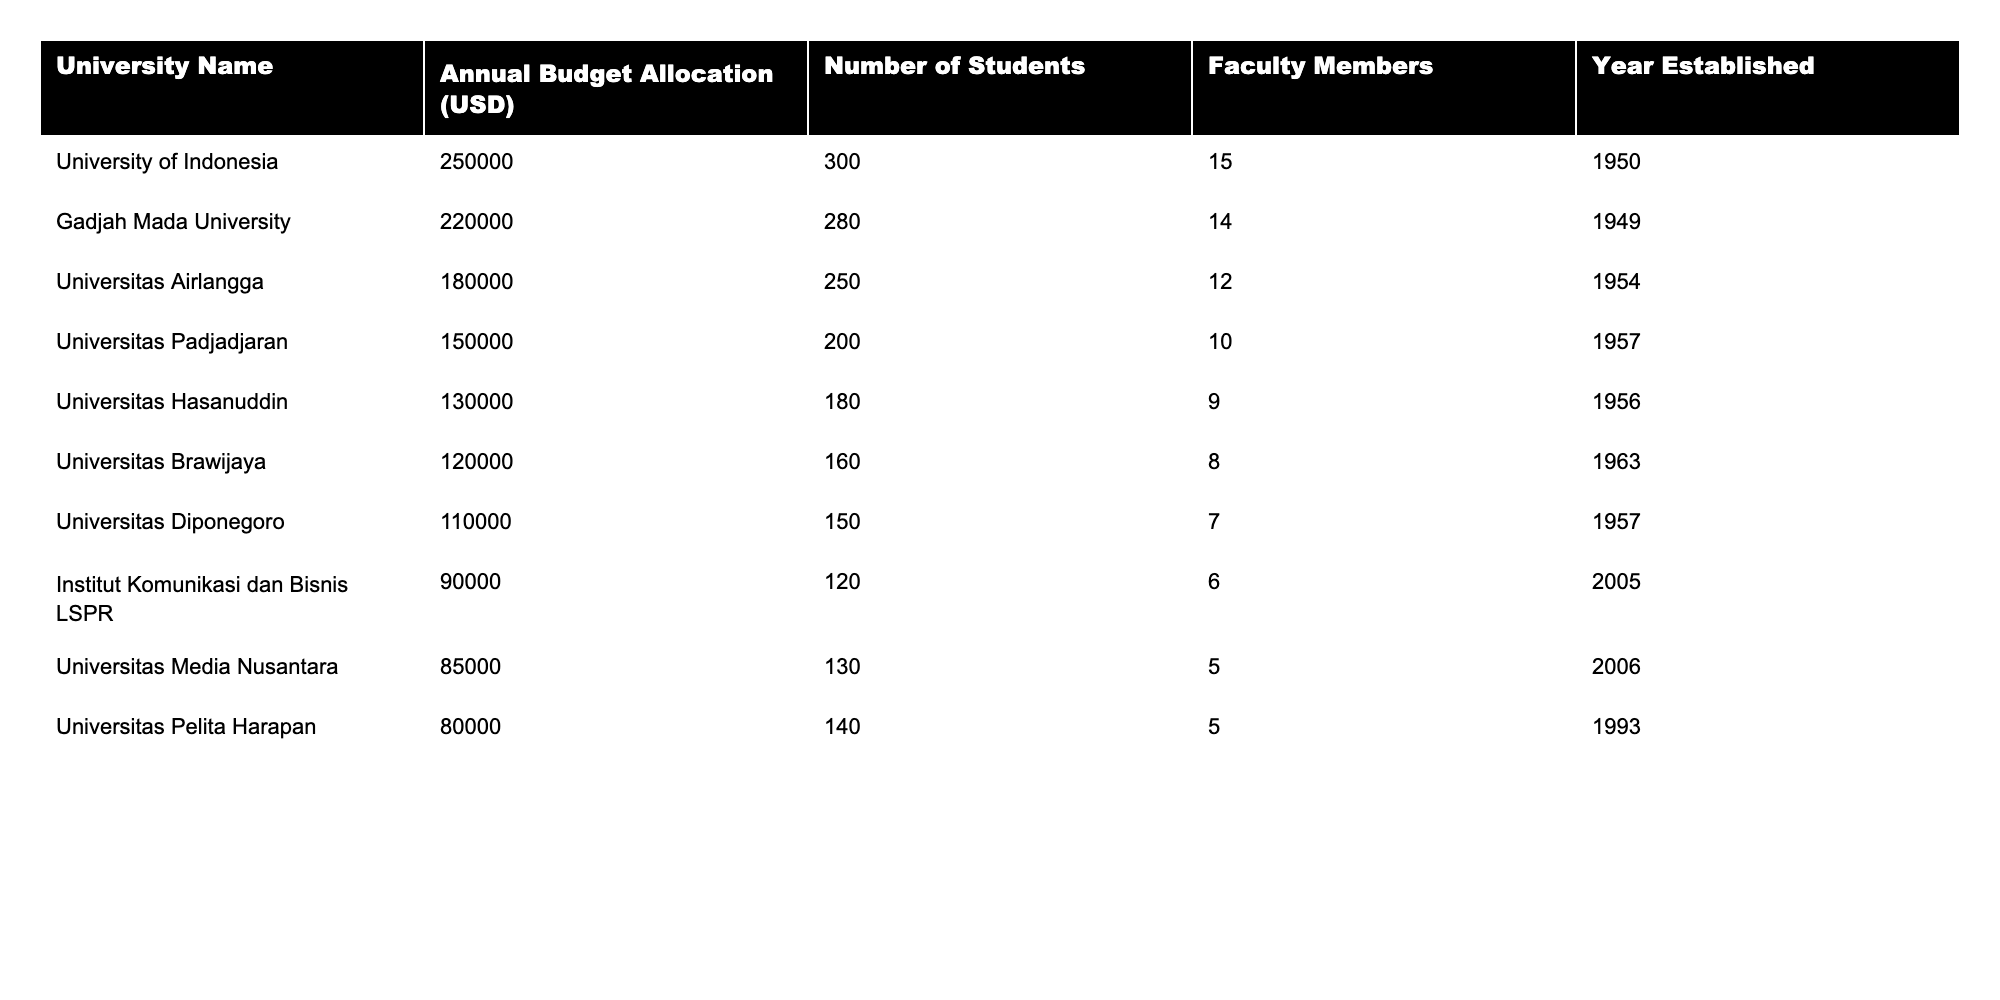What is the annual budget allocation for the University of Indonesia? The table shows the annual budget allocation for each university. For the University of Indonesia, it is listed as 250,000 USD.
Answer: 250,000 USD Which university has the lowest annual budget allocation? By looking at the table, Universitas Pelita Harapan has the lowest annual budget allocation of 80,000 USD.
Answer: Universitas Pelita Harapan What is the total number of students across all listed universities? To find the total number of students, we sum the number of students from each university: 300 + 280 + 250 + 200 + 180 + 160 + 150 + 120 + 130 + 140 = 1960.
Answer: 1960 students What is the average annual budget allocation of the universities in the table? First, we sum the budget allocations: 250000 + 220000 + 180000 + 150000 + 130000 + 120000 + 110000 + 90000 + 85000 + 80000 = 1150000. Then, divide by the number of universities (10): 1150000 / 10 = 115000.
Answer: 115,000 USD Is the number of faculty members at Gadjah Mada University higher than that at Universitas Hasanuddin? Gadjah Mada University has 14 faculty members, while Universitas Hasanuddin has 9. Since 14 is greater than 9, the statement is true.
Answer: Yes Which university, established before 1955, has the highest number of students? The universities established before 1955 are University of Indonesia (300 students), Gadjah Mada University (280 students), Universitas Airlangga (250 students), and Universitas Hasanuddin (180 students). Among these, University of Indonesia has the highest number of 300 students.
Answer: University of Indonesia If we only consider universities established after 2000, what is the total budget allocation? The universities established after 2000 are Institut Komunikasi dan Bisnis LSPR (90,000 USD) and Universitas Media Nusantara (85,000 USD). Adding these together gives us: 90000 + 85000 = 175000 USD.
Answer: 175,000 USD How many faculty members does the university with the largest budget allocation have? The university with the largest budget allocation is the University of Indonesia with 250,000 USD, which has 15 faculty members.
Answer: 15 faculty members Which university has a higher number of students: Universitas Diponegoro or Universitas Padjadjaran? Universitas Diponegoro has 150 students, while Universitas Padjadjaran has 200 students. Since 200 is greater than 150, Universitas Padjadjaran has more students.
Answer: Universitas Padjadjaran What percentage of the total budget allocation does the University of Indonesia represent? First, find the total budget allocation as previously calculated: 1,150,000 USD. Then, calculate the percentage: (250,000 / 1,150,000) * 100 = 21.74%.
Answer: 21.74% 